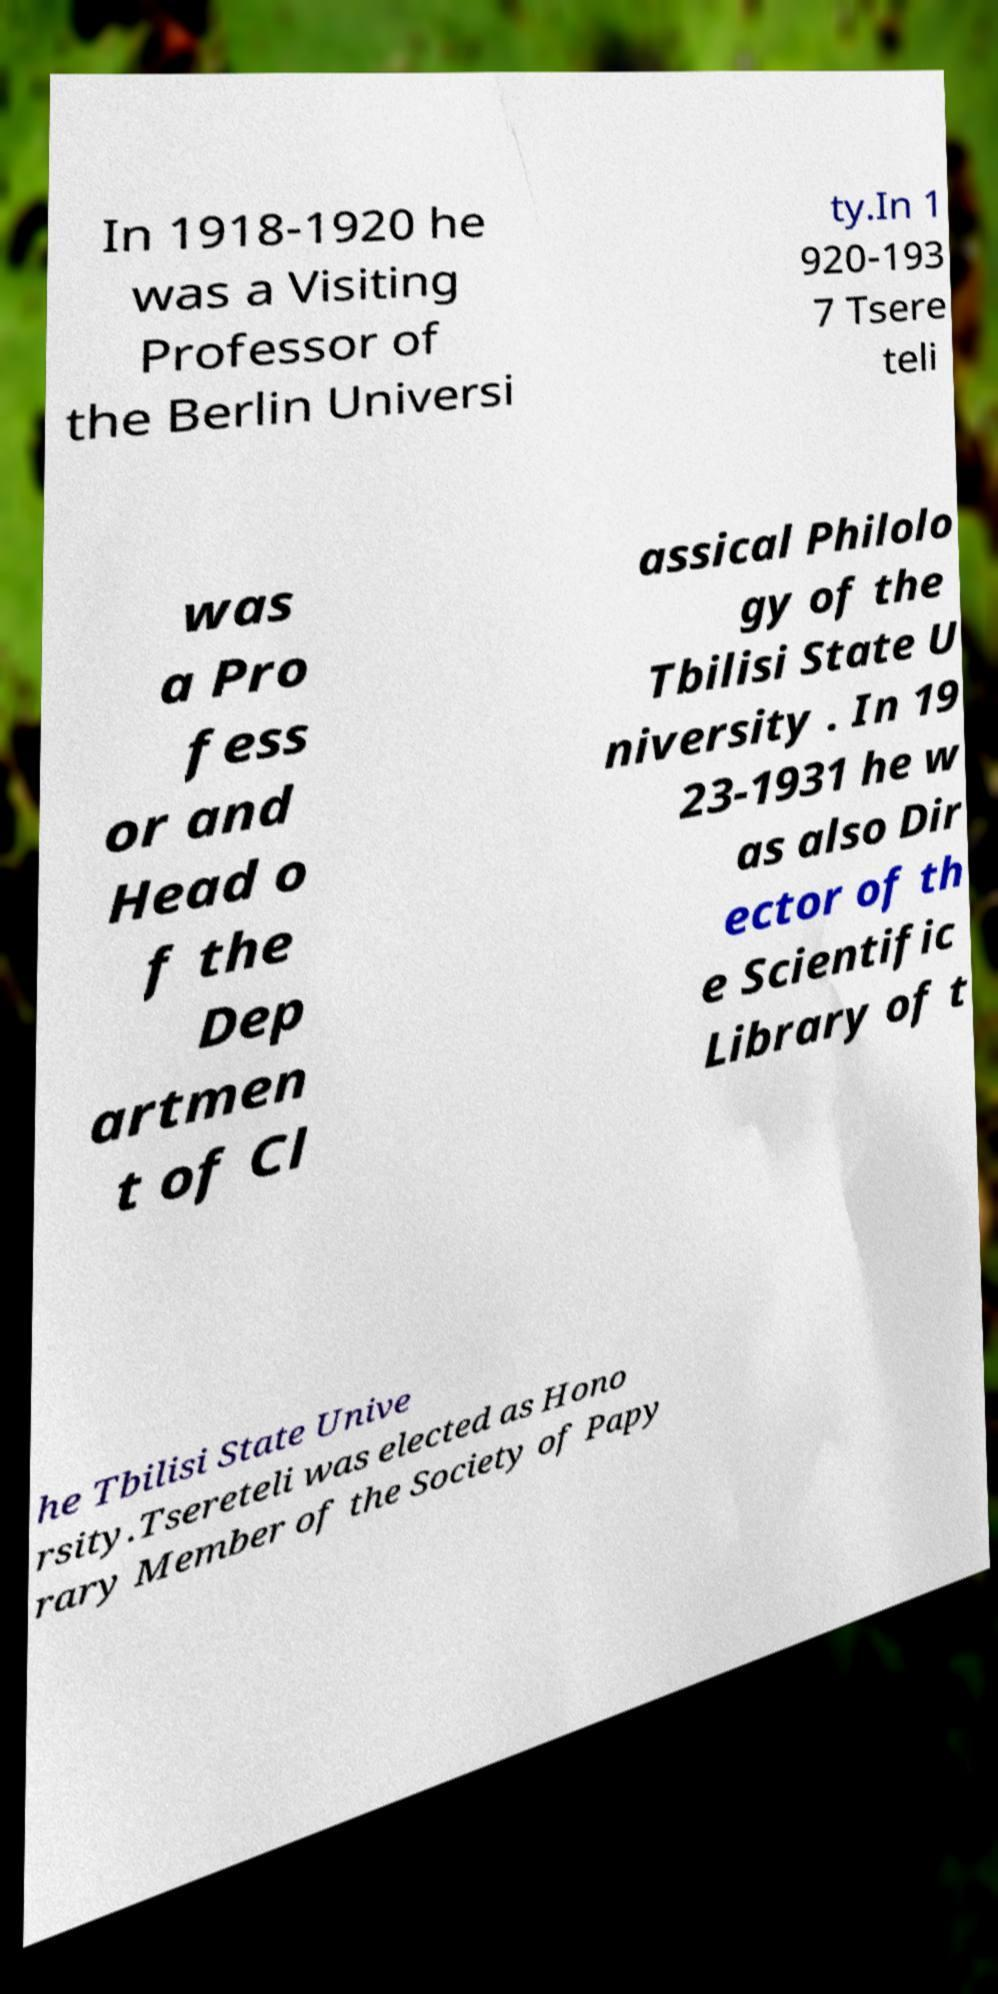Could you assist in decoding the text presented in this image and type it out clearly? In 1918-1920 he was a Visiting Professor of the Berlin Universi ty.In 1 920-193 7 Tsere teli was a Pro fess or and Head o f the Dep artmen t of Cl assical Philolo gy of the Tbilisi State U niversity . In 19 23-1931 he w as also Dir ector of th e Scientific Library of t he Tbilisi State Unive rsity.Tsereteli was elected as Hono rary Member of the Society of Papy 